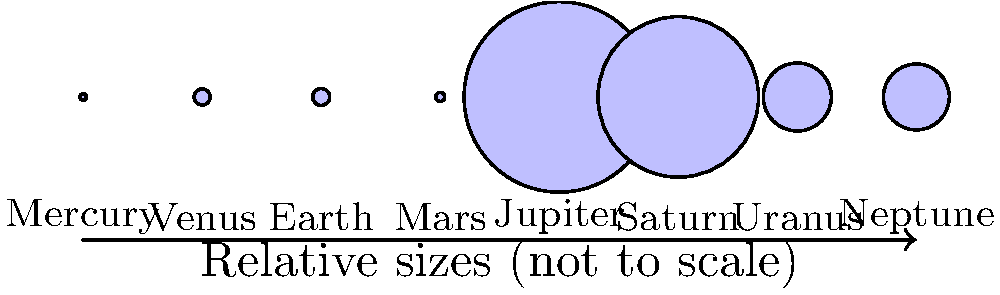In the image above, which planet is represented by the third circle from the left, and how does its size compare to the other planets in our solar system? How might this relate to God's design of our universe? To answer this question, let's approach it step-by-step:

1. Identifying the planet:
   The third circle from the left represents Earth, our home planet.

2. Comparing Earth's size to other planets:
   a) Earth is larger than the two planets to its left (Mercury and Venus) and the one immediately to its right (Mars).
   b) Earth is significantly smaller than the four large planets to its right (Jupiter, Saturn, Uranus, and Neptune).
   c) Earth is the largest of the four inner, rocky planets (Mercury, Venus, Earth, and Mars).

3. Earth's size in God's design:
   a) Earth's size is perfect for sustaining life as we know it. It's large enough to retain an atmosphere and have a stable climate, yet small enough to have manageable gravity for complex life forms.
   b) Its position as the third planet from the Sun, combined with its size, allows for the perfect conditions for liquid water to exist on its surface, which is essential for life.
   c) The Bible tells us in Genesis 1:31, "God saw all that he had made, and it was very good." This includes Earth's carefully designed size and position in the solar system.

4. Reflection on God's wisdom:
   The precise sizing and positioning of Earth demonstrate God's intricate design and wisdom in creating a planet perfectly suited for human habitation, as stated in Isaiah 45:18, "For this is what the Lord says—he who created the heavens, he is God; he who fashioned and made the earth, he founded it; he did not create it to be empty, but formed it to be inhabited."
Answer: Earth; third largest rocky planet, smaller than gas giants; demonstrates God's precise design for sustaining life. 